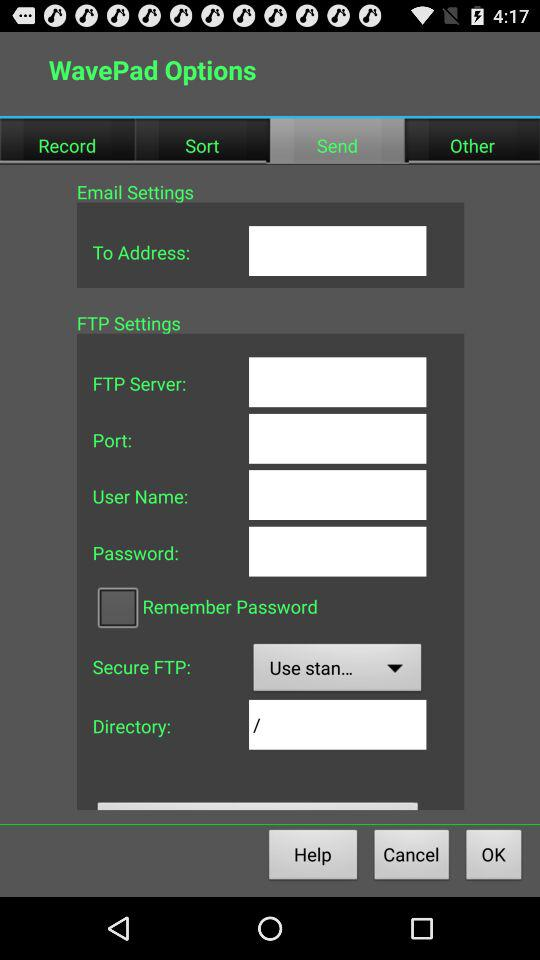What is the current status of the "Remember Password" setting? The current status is "off". 